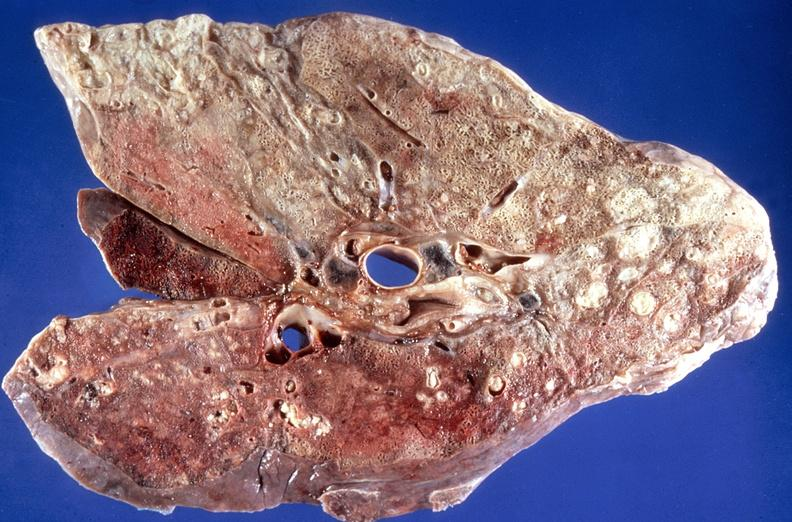what is present?
Answer the question using a single word or phrase. Respiratory 